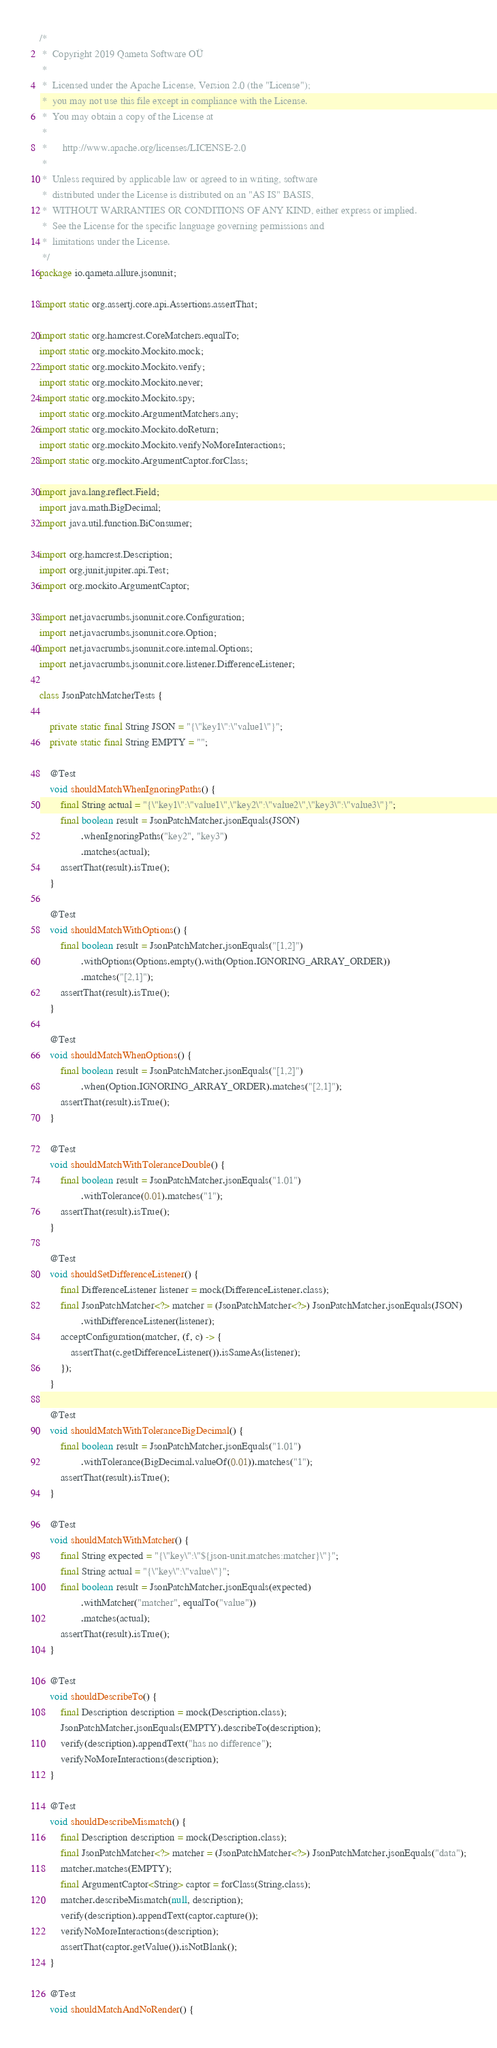Convert code to text. <code><loc_0><loc_0><loc_500><loc_500><_Java_>/*
 *  Copyright 2019 Qameta Software OÜ
 *
 *  Licensed under the Apache License, Version 2.0 (the "License");
 *  you may not use this file except in compliance with the License.
 *  You may obtain a copy of the License at
 *
 *      http://www.apache.org/licenses/LICENSE-2.0
 *
 *  Unless required by applicable law or agreed to in writing, software
 *  distributed under the License is distributed on an "AS IS" BASIS,
 *  WITHOUT WARRANTIES OR CONDITIONS OF ANY KIND, either express or implied.
 *  See the License for the specific language governing permissions and
 *  limitations under the License.
 */
package io.qameta.allure.jsonunit;

import static org.assertj.core.api.Assertions.assertThat;

import static org.hamcrest.CoreMatchers.equalTo;
import static org.mockito.Mockito.mock;
import static org.mockito.Mockito.verify;
import static org.mockito.Mockito.never;
import static org.mockito.Mockito.spy;
import static org.mockito.ArgumentMatchers.any;
import static org.mockito.Mockito.doReturn;
import static org.mockito.Mockito.verifyNoMoreInteractions;
import static org.mockito.ArgumentCaptor.forClass;

import java.lang.reflect.Field;
import java.math.BigDecimal;
import java.util.function.BiConsumer;

import org.hamcrest.Description;
import org.junit.jupiter.api.Test;
import org.mockito.ArgumentCaptor;

import net.javacrumbs.jsonunit.core.Configuration;
import net.javacrumbs.jsonunit.core.Option;
import net.javacrumbs.jsonunit.core.internal.Options;
import net.javacrumbs.jsonunit.core.listener.DifferenceListener;

class JsonPatchMatcherTests {

    private static final String JSON = "{\"key1\":\"value1\"}";
    private static final String EMPTY = "";

    @Test
    void shouldMatchWhenIgnoringPaths() {
        final String actual = "{\"key1\":\"value1\",\"key2\":\"value2\",\"key3\":\"value3\"}";
        final boolean result = JsonPatchMatcher.jsonEquals(JSON)
                .whenIgnoringPaths("key2", "key3")
                .matches(actual);
        assertThat(result).isTrue();
    }

    @Test
    void shouldMatchWithOptions() {
        final boolean result = JsonPatchMatcher.jsonEquals("[1,2]")
                .withOptions(Options.empty().with(Option.IGNORING_ARRAY_ORDER))
                .matches("[2,1]");
        assertThat(result).isTrue();
    }

    @Test
    void shouldMatchWhenOptions() {
        final boolean result = JsonPatchMatcher.jsonEquals("[1,2]")
                .when(Option.IGNORING_ARRAY_ORDER).matches("[2,1]");
        assertThat(result).isTrue();
    }

    @Test
    void shouldMatchWithToleranceDouble() {
        final boolean result = JsonPatchMatcher.jsonEquals("1.01")
                .withTolerance(0.01).matches("1");
        assertThat(result).isTrue();
    }

    @Test
    void shouldSetDifferenceListener() {
        final DifferenceListener listener = mock(DifferenceListener.class);
        final JsonPatchMatcher<?> matcher = (JsonPatchMatcher<?>) JsonPatchMatcher.jsonEquals(JSON)
                .withDifferenceListener(listener);
        acceptConfiguration(matcher, (f, c) -> {
            assertThat(c.getDifferenceListener()).isSameAs(listener);
        });
    }

    @Test
    void shouldMatchWithToleranceBigDecimal() {
        final boolean result = JsonPatchMatcher.jsonEquals("1.01")
                .withTolerance(BigDecimal.valueOf(0.01)).matches("1");
        assertThat(result).isTrue();
    }

    @Test
    void shouldMatchWithMatcher() {
        final String expected = "{\"key\":\"${json-unit.matches:matcher}\"}";
        final String actual = "{\"key\":\"value\"}";
        final boolean result = JsonPatchMatcher.jsonEquals(expected)
                .withMatcher("matcher", equalTo("value"))
                .matches(actual);
        assertThat(result).isTrue();
    }

    @Test
    void shouldDescribeTo() {
        final Description description = mock(Description.class);
        JsonPatchMatcher.jsonEquals(EMPTY).describeTo(description);
        verify(description).appendText("has no difference");
        verifyNoMoreInteractions(description);
    }

    @Test
    void shouldDescribeMismatch() {
        final Description description = mock(Description.class);
        final JsonPatchMatcher<?> matcher = (JsonPatchMatcher<?>) JsonPatchMatcher.jsonEquals("data");
        matcher.matches(EMPTY);
        final ArgumentCaptor<String> captor = forClass(String.class);
        matcher.describeMismatch(null, description);
        verify(description).appendText(captor.capture());
        verifyNoMoreInteractions(description);
        assertThat(captor.getValue()).isNotBlank();
    }

    @Test
    void shouldMatchAndNoRender() {</code> 